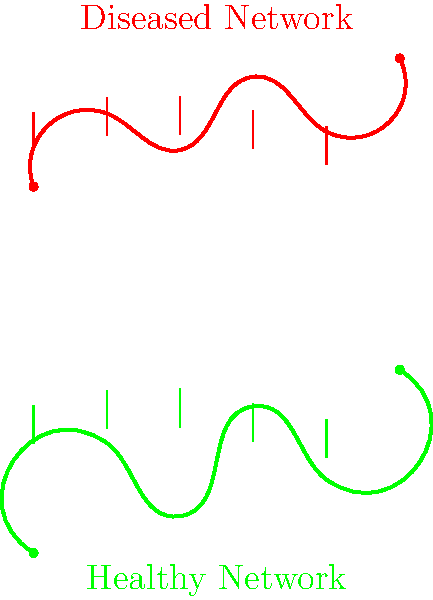Based on the visual comparison of healthy versus diseased mycorrhizal networks in forest ecosystems, what is the primary difference in the structural integrity of the fungal hyphae between the two networks? To answer this question, we need to analyze the visual representation of the healthy and diseased mycorrhizal networks:

1. Observe the healthy network (green):
   - The line is continuous and smooth
   - The fungal hyphae (vertical lines) are evenly distributed and uniform in length

2. Examine the diseased network (red):
   - The line is more irregular and jagged
   - The fungal hyphae are shorter and less uniform in distribution

3. Compare the two networks:
   - The healthy network shows a more robust and interconnected structure
   - The diseased network appears fragmented and less cohesive

4. Interpret the structural differences:
   - The healthy network's smooth line and uniform hyphae suggest strong connections between plant roots and fungi
   - The diseased network's jagged line and irregular hyphae indicate weakened or broken connections

5. Conclude the primary difference:
   - The healthy network maintains structural integrity with strong, uniform connections
   - The diseased network shows a loss of structural integrity due to fragmentation and weakened connections

Therefore, the primary difference in structural integrity is the continuity and uniformity of connections within the network.
Answer: Continuity and uniformity of connections 